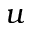<formula> <loc_0><loc_0><loc_500><loc_500>u</formula> 